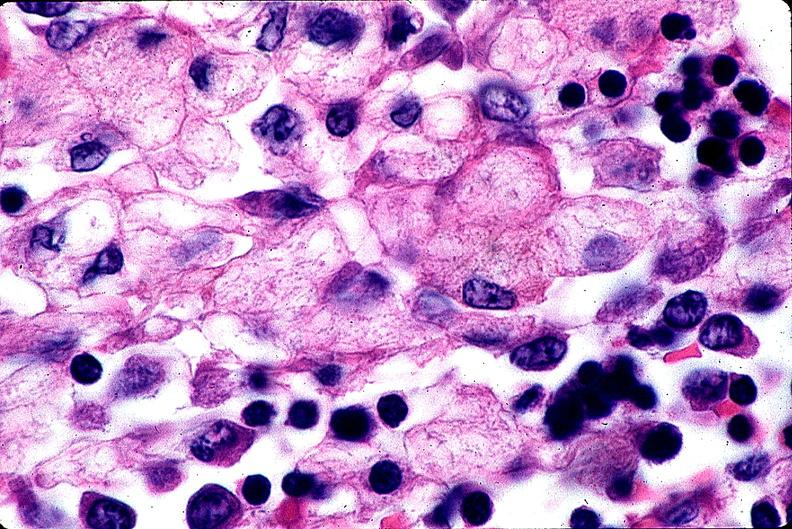does this image show gaucher disease?
Answer the question using a single word or phrase. Yes 